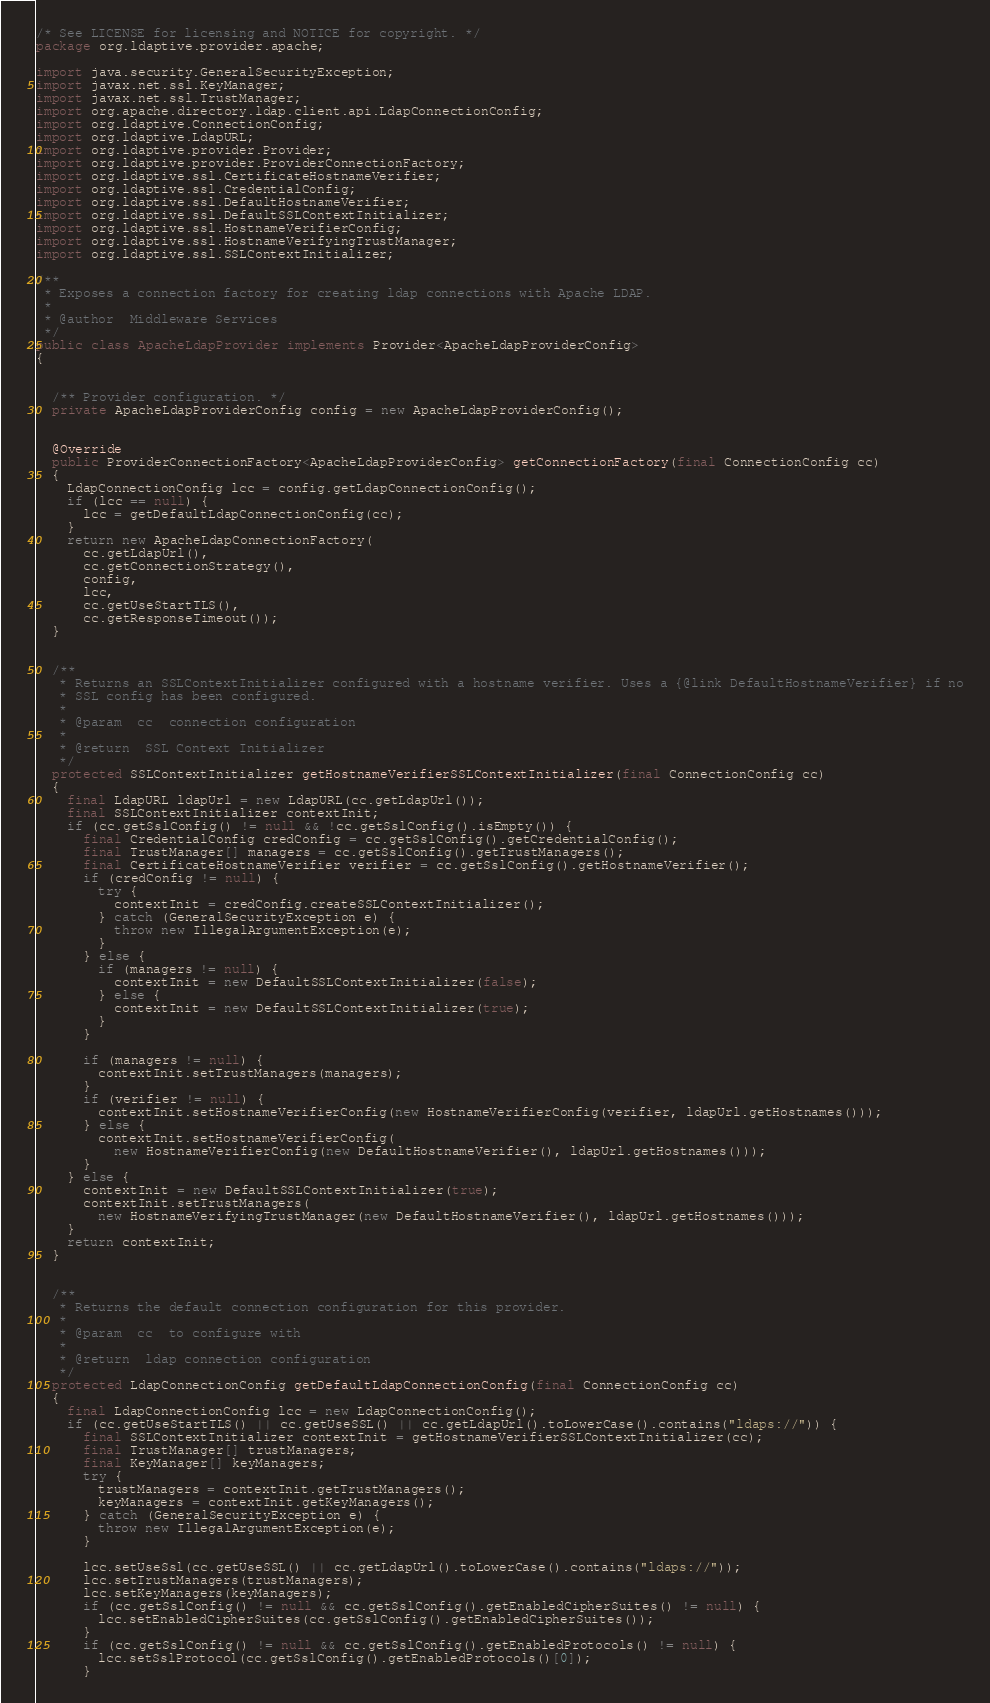<code> <loc_0><loc_0><loc_500><loc_500><_Java_>/* See LICENSE for licensing and NOTICE for copyright. */
package org.ldaptive.provider.apache;

import java.security.GeneralSecurityException;
import javax.net.ssl.KeyManager;
import javax.net.ssl.TrustManager;
import org.apache.directory.ldap.client.api.LdapConnectionConfig;
import org.ldaptive.ConnectionConfig;
import org.ldaptive.LdapURL;
import org.ldaptive.provider.Provider;
import org.ldaptive.provider.ProviderConnectionFactory;
import org.ldaptive.ssl.CertificateHostnameVerifier;
import org.ldaptive.ssl.CredentialConfig;
import org.ldaptive.ssl.DefaultHostnameVerifier;
import org.ldaptive.ssl.DefaultSSLContextInitializer;
import org.ldaptive.ssl.HostnameVerifierConfig;
import org.ldaptive.ssl.HostnameVerifyingTrustManager;
import org.ldaptive.ssl.SSLContextInitializer;

/**
 * Exposes a connection factory for creating ldap connections with Apache LDAP.
 *
 * @author  Middleware Services
 */
public class ApacheLdapProvider implements Provider<ApacheLdapProviderConfig>
{


  /** Provider configuration. */
  private ApacheLdapProviderConfig config = new ApacheLdapProviderConfig();


  @Override
  public ProviderConnectionFactory<ApacheLdapProviderConfig> getConnectionFactory(final ConnectionConfig cc)
  {
    LdapConnectionConfig lcc = config.getLdapConnectionConfig();
    if (lcc == null) {
      lcc = getDefaultLdapConnectionConfig(cc);
    }
    return new ApacheLdapConnectionFactory(
      cc.getLdapUrl(),
      cc.getConnectionStrategy(),
      config,
      lcc,
      cc.getUseStartTLS(),
      cc.getResponseTimeout());
  }


  /**
   * Returns an SSLContextInitializer configured with a hostname verifier. Uses a {@link DefaultHostnameVerifier} if no
   * SSL config has been configured.
   *
   * @param  cc  connection configuration
   *
   * @return  SSL Context Initializer
   */
  protected SSLContextInitializer getHostnameVerifierSSLContextInitializer(final ConnectionConfig cc)
  {
    final LdapURL ldapUrl = new LdapURL(cc.getLdapUrl());
    final SSLContextInitializer contextInit;
    if (cc.getSslConfig() != null && !cc.getSslConfig().isEmpty()) {
      final CredentialConfig credConfig = cc.getSslConfig().getCredentialConfig();
      final TrustManager[] managers = cc.getSslConfig().getTrustManagers();
      final CertificateHostnameVerifier verifier = cc.getSslConfig().getHostnameVerifier();
      if (credConfig != null) {
        try {
          contextInit = credConfig.createSSLContextInitializer();
        } catch (GeneralSecurityException e) {
          throw new IllegalArgumentException(e);
        }
      } else {
        if (managers != null) {
          contextInit = new DefaultSSLContextInitializer(false);
        } else {
          contextInit = new DefaultSSLContextInitializer(true);
        }
      }

      if (managers != null) {
        contextInit.setTrustManagers(managers);
      }
      if (verifier != null) {
        contextInit.setHostnameVerifierConfig(new HostnameVerifierConfig(verifier, ldapUrl.getHostnames()));
      } else {
        contextInit.setHostnameVerifierConfig(
          new HostnameVerifierConfig(new DefaultHostnameVerifier(), ldapUrl.getHostnames()));
      }
    } else {
      contextInit = new DefaultSSLContextInitializer(true);
      contextInit.setTrustManagers(
        new HostnameVerifyingTrustManager(new DefaultHostnameVerifier(), ldapUrl.getHostnames()));
    }
    return contextInit;
  }


  /**
   * Returns the default connection configuration for this provider.
   *
   * @param  cc  to configure with
   *
   * @return  ldap connection configuration
   */
  protected LdapConnectionConfig getDefaultLdapConnectionConfig(final ConnectionConfig cc)
  {
    final LdapConnectionConfig lcc = new LdapConnectionConfig();
    if (cc.getUseStartTLS() || cc.getUseSSL() || cc.getLdapUrl().toLowerCase().contains("ldaps://")) {
      final SSLContextInitializer contextInit = getHostnameVerifierSSLContextInitializer(cc);
      final TrustManager[] trustManagers;
      final KeyManager[] keyManagers;
      try {
        trustManagers = contextInit.getTrustManagers();
        keyManagers = contextInit.getKeyManagers();
      } catch (GeneralSecurityException e) {
        throw new IllegalArgumentException(e);
      }

      lcc.setUseSsl(cc.getUseSSL() || cc.getLdapUrl().toLowerCase().contains("ldaps://"));
      lcc.setTrustManagers(trustManagers);
      lcc.setKeyManagers(keyManagers);
      if (cc.getSslConfig() != null && cc.getSslConfig().getEnabledCipherSuites() != null) {
        lcc.setEnabledCipherSuites(cc.getSslConfig().getEnabledCipherSuites());
      }
      if (cc.getSslConfig() != null && cc.getSslConfig().getEnabledProtocols() != null) {
        lcc.setSslProtocol(cc.getSslConfig().getEnabledProtocols()[0]);
      }</code> 